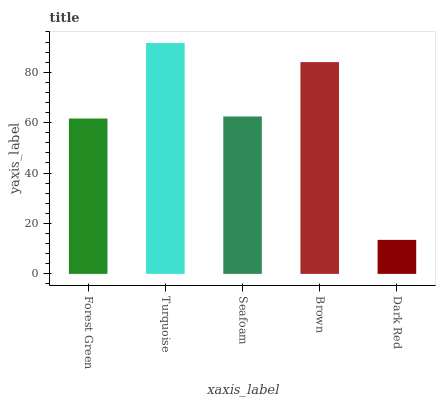Is Dark Red the minimum?
Answer yes or no. Yes. Is Turquoise the maximum?
Answer yes or no. Yes. Is Seafoam the minimum?
Answer yes or no. No. Is Seafoam the maximum?
Answer yes or no. No. Is Turquoise greater than Seafoam?
Answer yes or no. Yes. Is Seafoam less than Turquoise?
Answer yes or no. Yes. Is Seafoam greater than Turquoise?
Answer yes or no. No. Is Turquoise less than Seafoam?
Answer yes or no. No. Is Seafoam the high median?
Answer yes or no. Yes. Is Seafoam the low median?
Answer yes or no. Yes. Is Brown the high median?
Answer yes or no. No. Is Dark Red the low median?
Answer yes or no. No. 